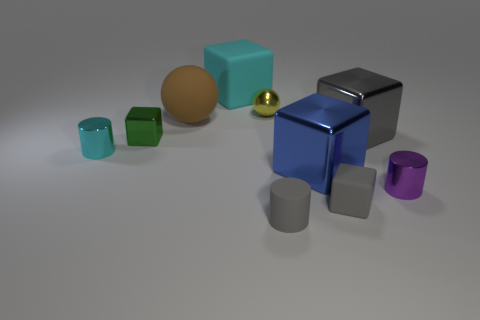Subtract all green cubes. How many cubes are left? 4 Subtract all tiny gray matte blocks. How many blocks are left? 4 Subtract all purple blocks. Subtract all purple cylinders. How many blocks are left? 5 Subtract all cylinders. How many objects are left? 7 Add 8 red rubber spheres. How many red rubber spheres exist? 8 Subtract 1 gray cubes. How many objects are left? 9 Subtract all tiny yellow metal cylinders. Subtract all small gray cylinders. How many objects are left? 9 Add 2 big gray metallic blocks. How many big gray metallic blocks are left? 3 